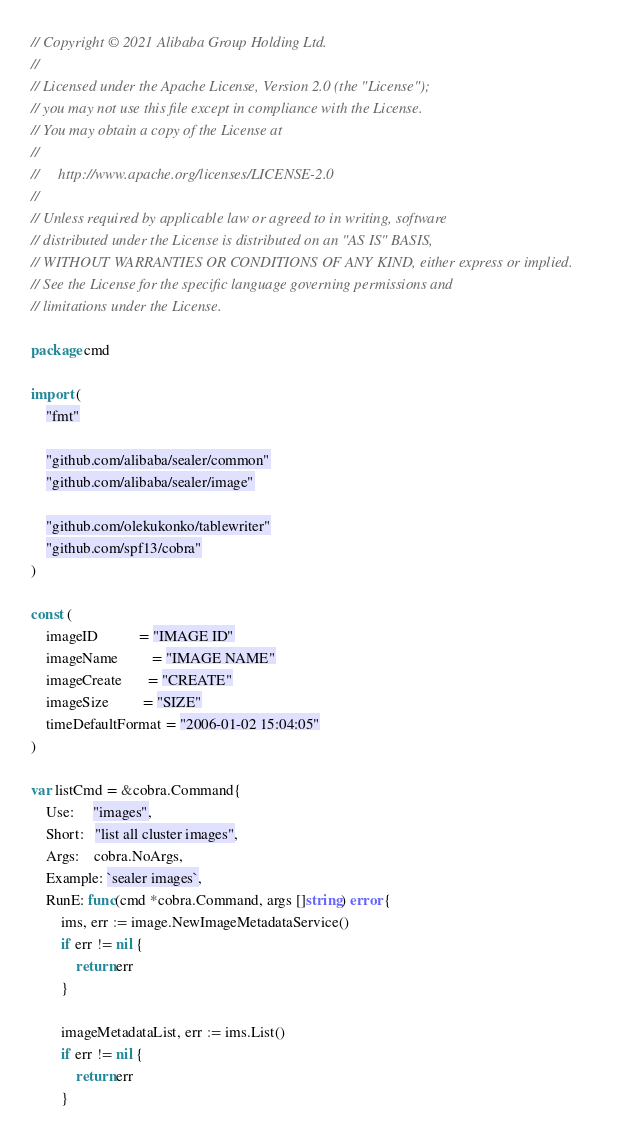<code> <loc_0><loc_0><loc_500><loc_500><_Go_>// Copyright © 2021 Alibaba Group Holding Ltd.
//
// Licensed under the Apache License, Version 2.0 (the "License");
// you may not use this file except in compliance with the License.
// You may obtain a copy of the License at
//
//     http://www.apache.org/licenses/LICENSE-2.0
//
// Unless required by applicable law or agreed to in writing, software
// distributed under the License is distributed on an "AS IS" BASIS,
// WITHOUT WARRANTIES OR CONDITIONS OF ANY KIND, either express or implied.
// See the License for the specific language governing permissions and
// limitations under the License.

package cmd

import (
	"fmt"

	"github.com/alibaba/sealer/common"
	"github.com/alibaba/sealer/image"

	"github.com/olekukonko/tablewriter"
	"github.com/spf13/cobra"
)

const (
	imageID           = "IMAGE ID"
	imageName         = "IMAGE NAME"
	imageCreate       = "CREATE"
	imageSize         = "SIZE"
	timeDefaultFormat = "2006-01-02 15:04:05"
)

var listCmd = &cobra.Command{
	Use:     "images",
	Short:   "list all cluster images",
	Args:    cobra.NoArgs,
	Example: `sealer images`,
	RunE: func(cmd *cobra.Command, args []string) error {
		ims, err := image.NewImageMetadataService()
		if err != nil {
			return err
		}

		imageMetadataList, err := ims.List()
		if err != nil {
			return err
		}</code> 